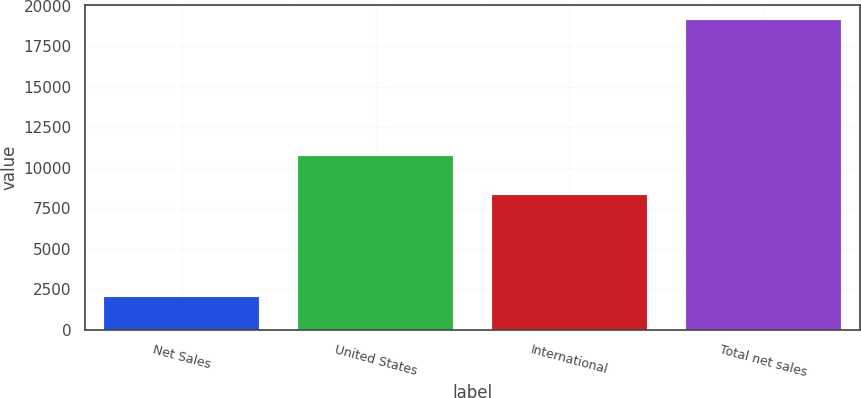Convert chart. <chart><loc_0><loc_0><loc_500><loc_500><bar_chart><fcel>Net Sales<fcel>United States<fcel>International<fcel>Total net sales<nl><fcel>2015<fcel>10757<fcel>8353<fcel>19110<nl></chart> 